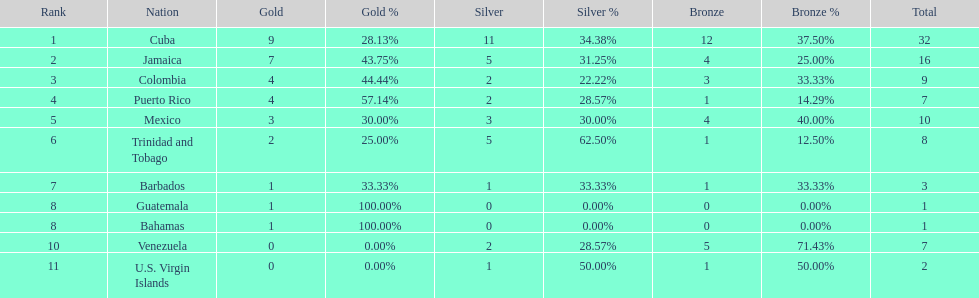What is the difference in medals between cuba and mexico? 22. Could you parse the entire table? {'header': ['Rank', 'Nation', 'Gold', 'Gold %', 'Silver', 'Silver %', 'Bronze', 'Bronze %', 'Total'], 'rows': [['1', 'Cuba', '9', '28.13%', '11', '34.38%', '12', '37.50%', '32'], ['2', 'Jamaica', '7', '43.75%', '5', '31.25%', '4', '25.00%', '16'], ['3', 'Colombia', '4', '44.44%', '2', '22.22%', '3', '33.33%', '9'], ['4', 'Puerto Rico', '4', '57.14%', '2', '28.57%', '1', '14.29%', '7'], ['5', 'Mexico', '3', '30.00%', '3', '30.00%', '4', '40.00%', '10'], ['6', 'Trinidad and Tobago', '2', '25.00%', '5', '62.50%', '1', '12.50%', '8'], ['7', 'Barbados', '1', '33.33%', '1', '33.33%', '1', '33.33%', '3'], ['8', 'Guatemala', '1', '100.00%', '0', '0.00%', '0', '0.00%', '1'], ['8', 'Bahamas', '1', '100.00%', '0', '0.00%', '0', '0.00%', '1'], ['10', 'Venezuela', '0', '0.00%', '2', '28.57%', '5', '71.43%', '7'], ['11', 'U.S. Virgin Islands', '0', '0.00%', '1', '50.00%', '1', '50.00%', '2']]} 